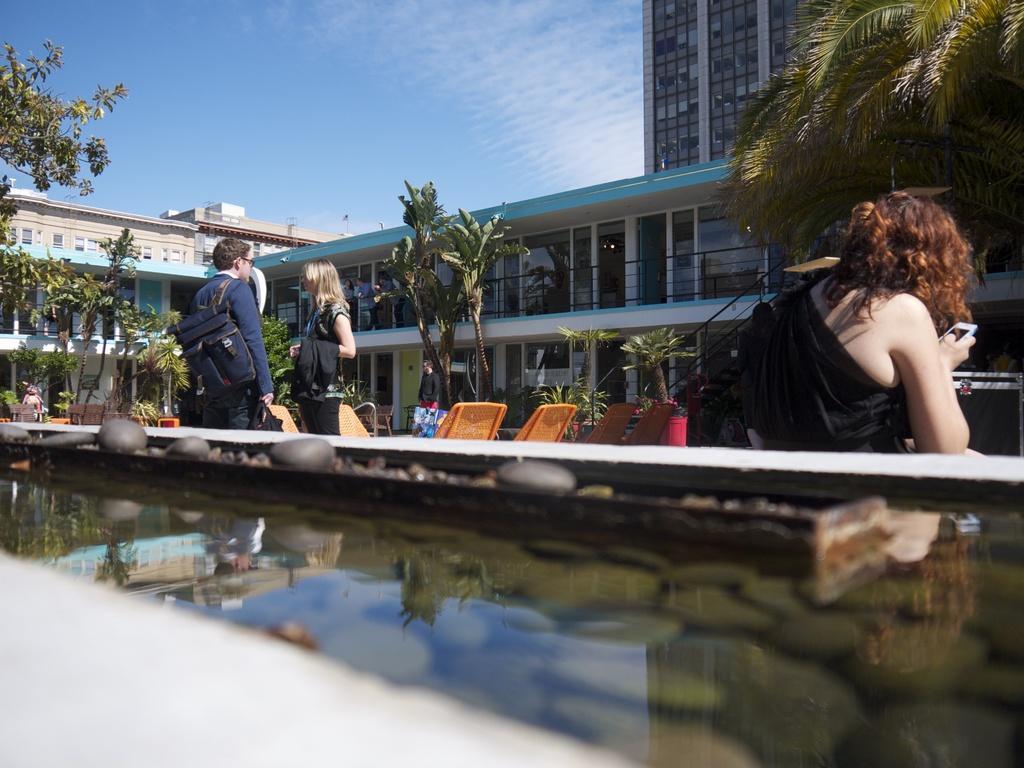Describe this image in one or two sentences. In this image we can see group of persons standing. One man wearing blue dress is wearing a bag and spectacles. In the background, we can see a group of buildings, trees and water and cloudy sky. 